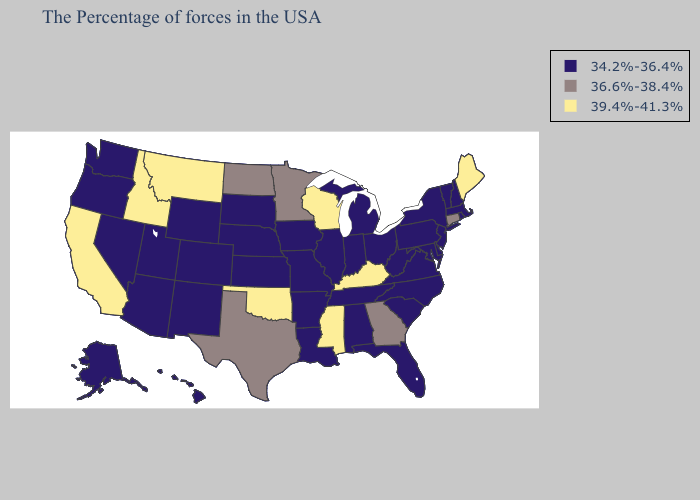Name the states that have a value in the range 39.4%-41.3%?
Quick response, please. Maine, Kentucky, Wisconsin, Mississippi, Oklahoma, Montana, Idaho, California. Name the states that have a value in the range 36.6%-38.4%?
Keep it brief. Connecticut, Georgia, Minnesota, Texas, North Dakota. Does New York have the lowest value in the Northeast?
Concise answer only. Yes. Among the states that border Florida , which have the highest value?
Quick response, please. Georgia. What is the lowest value in the MidWest?
Give a very brief answer. 34.2%-36.4%. What is the value of Pennsylvania?
Write a very short answer. 34.2%-36.4%. Name the states that have a value in the range 36.6%-38.4%?
Short answer required. Connecticut, Georgia, Minnesota, Texas, North Dakota. Name the states that have a value in the range 36.6%-38.4%?
Be succinct. Connecticut, Georgia, Minnesota, Texas, North Dakota. Name the states that have a value in the range 39.4%-41.3%?
Quick response, please. Maine, Kentucky, Wisconsin, Mississippi, Oklahoma, Montana, Idaho, California. What is the value of Louisiana?
Give a very brief answer. 34.2%-36.4%. Which states have the lowest value in the USA?
Keep it brief. Massachusetts, Rhode Island, New Hampshire, Vermont, New York, New Jersey, Delaware, Maryland, Pennsylvania, Virginia, North Carolina, South Carolina, West Virginia, Ohio, Florida, Michigan, Indiana, Alabama, Tennessee, Illinois, Louisiana, Missouri, Arkansas, Iowa, Kansas, Nebraska, South Dakota, Wyoming, Colorado, New Mexico, Utah, Arizona, Nevada, Washington, Oregon, Alaska, Hawaii. What is the value of Connecticut?
Answer briefly. 36.6%-38.4%. Name the states that have a value in the range 39.4%-41.3%?
Concise answer only. Maine, Kentucky, Wisconsin, Mississippi, Oklahoma, Montana, Idaho, California. Name the states that have a value in the range 39.4%-41.3%?
Write a very short answer. Maine, Kentucky, Wisconsin, Mississippi, Oklahoma, Montana, Idaho, California. What is the lowest value in the USA?
Be succinct. 34.2%-36.4%. 